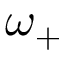<formula> <loc_0><loc_0><loc_500><loc_500>\omega _ { + }</formula> 